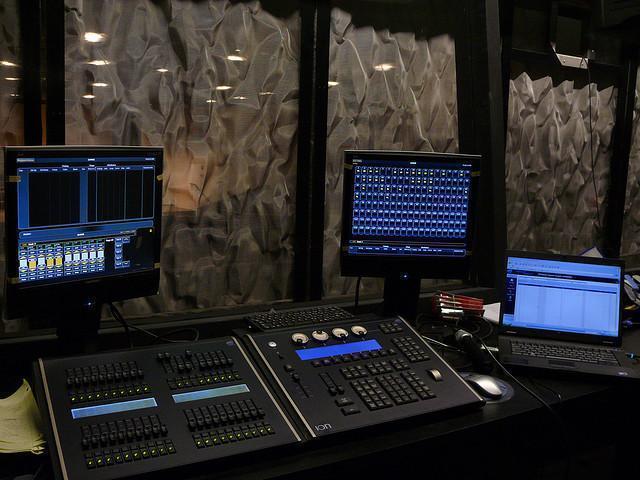The sliders on the equipment on the desk is used to adjust what?
Choose the right answer from the provided options to respond to the question.
Options: Lighting, sound, temperature, blinds. Lighting. 